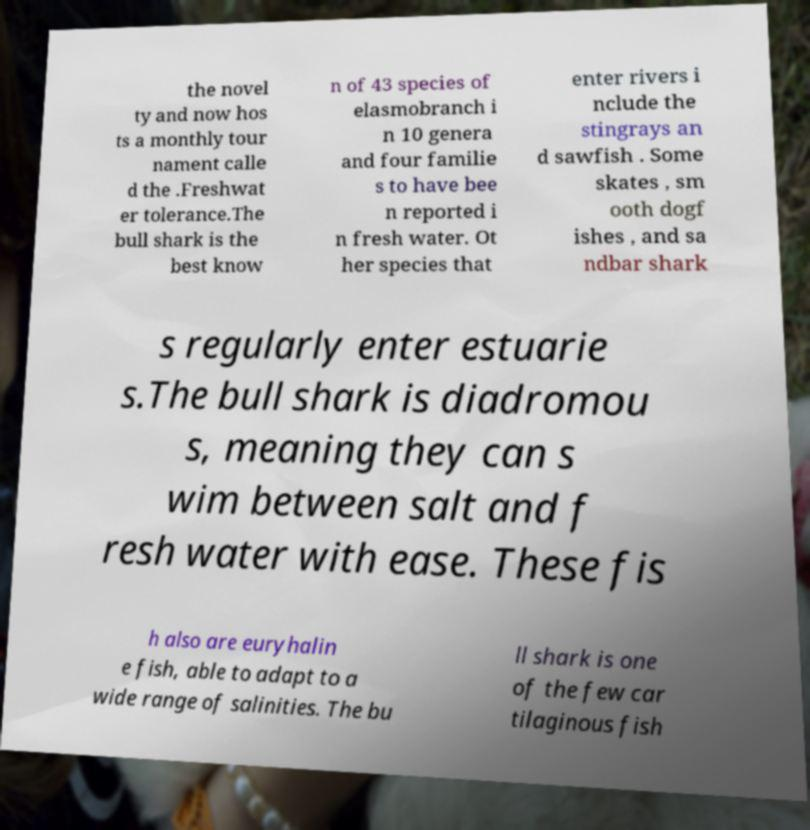Please read and relay the text visible in this image. What does it say? the novel ty and now hos ts a monthly tour nament calle d the .Freshwat er tolerance.The bull shark is the best know n of 43 species of elasmobranch i n 10 genera and four familie s to have bee n reported i n fresh water. Ot her species that enter rivers i nclude the stingrays an d sawfish . Some skates , sm ooth dogf ishes , and sa ndbar shark s regularly enter estuarie s.The bull shark is diadromou s, meaning they can s wim between salt and f resh water with ease. These fis h also are euryhalin e fish, able to adapt to a wide range of salinities. The bu ll shark is one of the few car tilaginous fish 